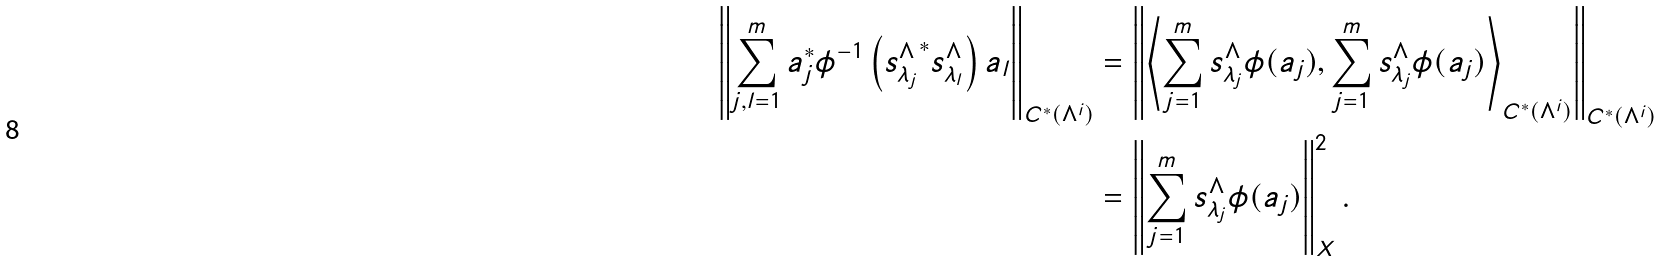<formula> <loc_0><loc_0><loc_500><loc_500>\left \| \sum _ { j , l = 1 } ^ { m } a _ { j } ^ { * } \phi ^ { - 1 } \left ( { s _ { \lambda _ { j } } ^ { \Lambda } } ^ { * } s _ { \lambda _ { l } } ^ { \Lambda } \right ) a _ { l } \right \| _ { C ^ { * } ( \Lambda ^ { i } ) } & = \left \| \left \langle \sum _ { j = 1 } ^ { m } s _ { \lambda _ { j } } ^ { \Lambda } \phi ( a _ { j } ) , \sum _ { j = 1 } ^ { m } s _ { \lambda _ { j } } ^ { \Lambda } \phi ( a _ { j } ) \right \rangle _ { C ^ { * } ( \Lambda ^ { i } ) } \right \| _ { C ^ { * } ( \Lambda ^ { i } ) } \\ & = \left \| \sum _ { j = 1 } ^ { m } s _ { \lambda _ { j } } ^ { \Lambda } \phi ( a _ { j } ) \right \| _ { X } ^ { 2 } .</formula> 